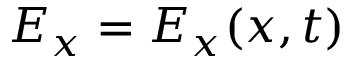<formula> <loc_0><loc_0><loc_500><loc_500>E _ { x } = E _ { x } ( x , t )</formula> 